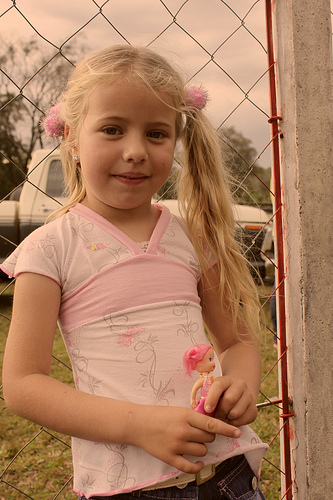<image>
Is the handle behind the doll? Yes. From this viewpoint, the handle is positioned behind the doll, with the doll partially or fully occluding the handle. 